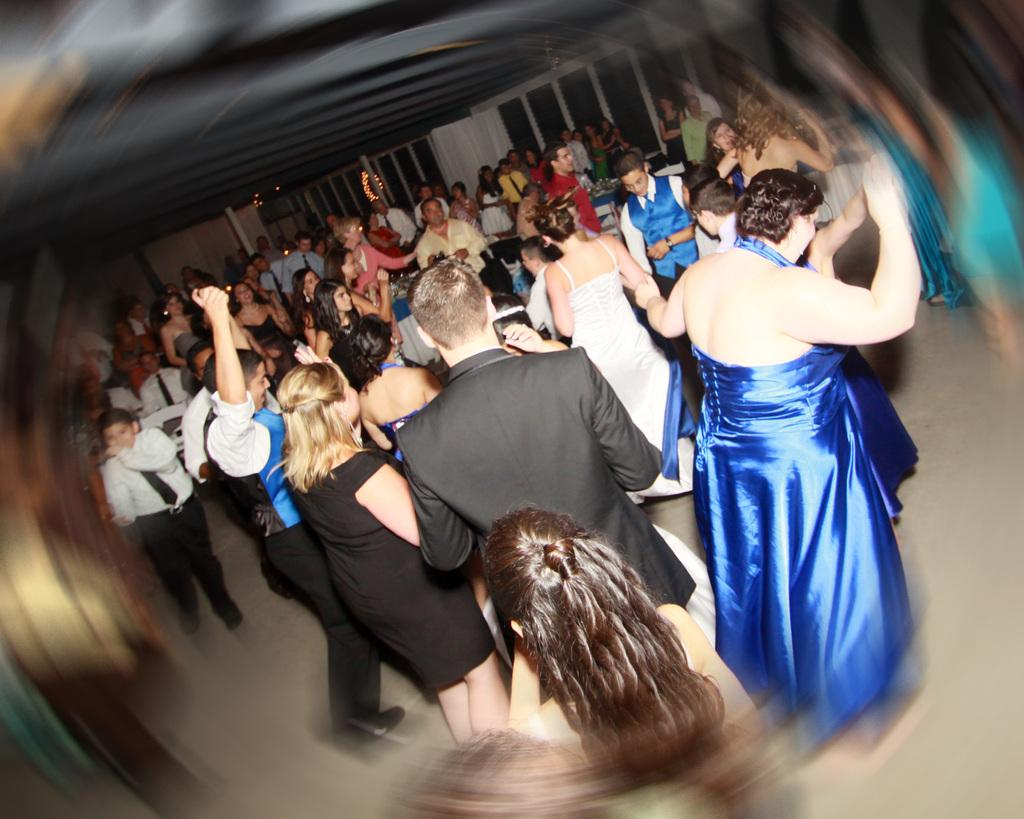What is the main subject of the image? The main subject of the image is a group of people. What are the people in the image doing? The people are standing. How can we differentiate the people in the image? The people are wearing different color dresses. What can be seen in the background of the image? There are windows and a wall visible in the background. What type of fruit is being served on a plate in the image? There is no plate or fruit present in the image. Can you tell me how many spades are visible in the image? There are no spades present in the image. 